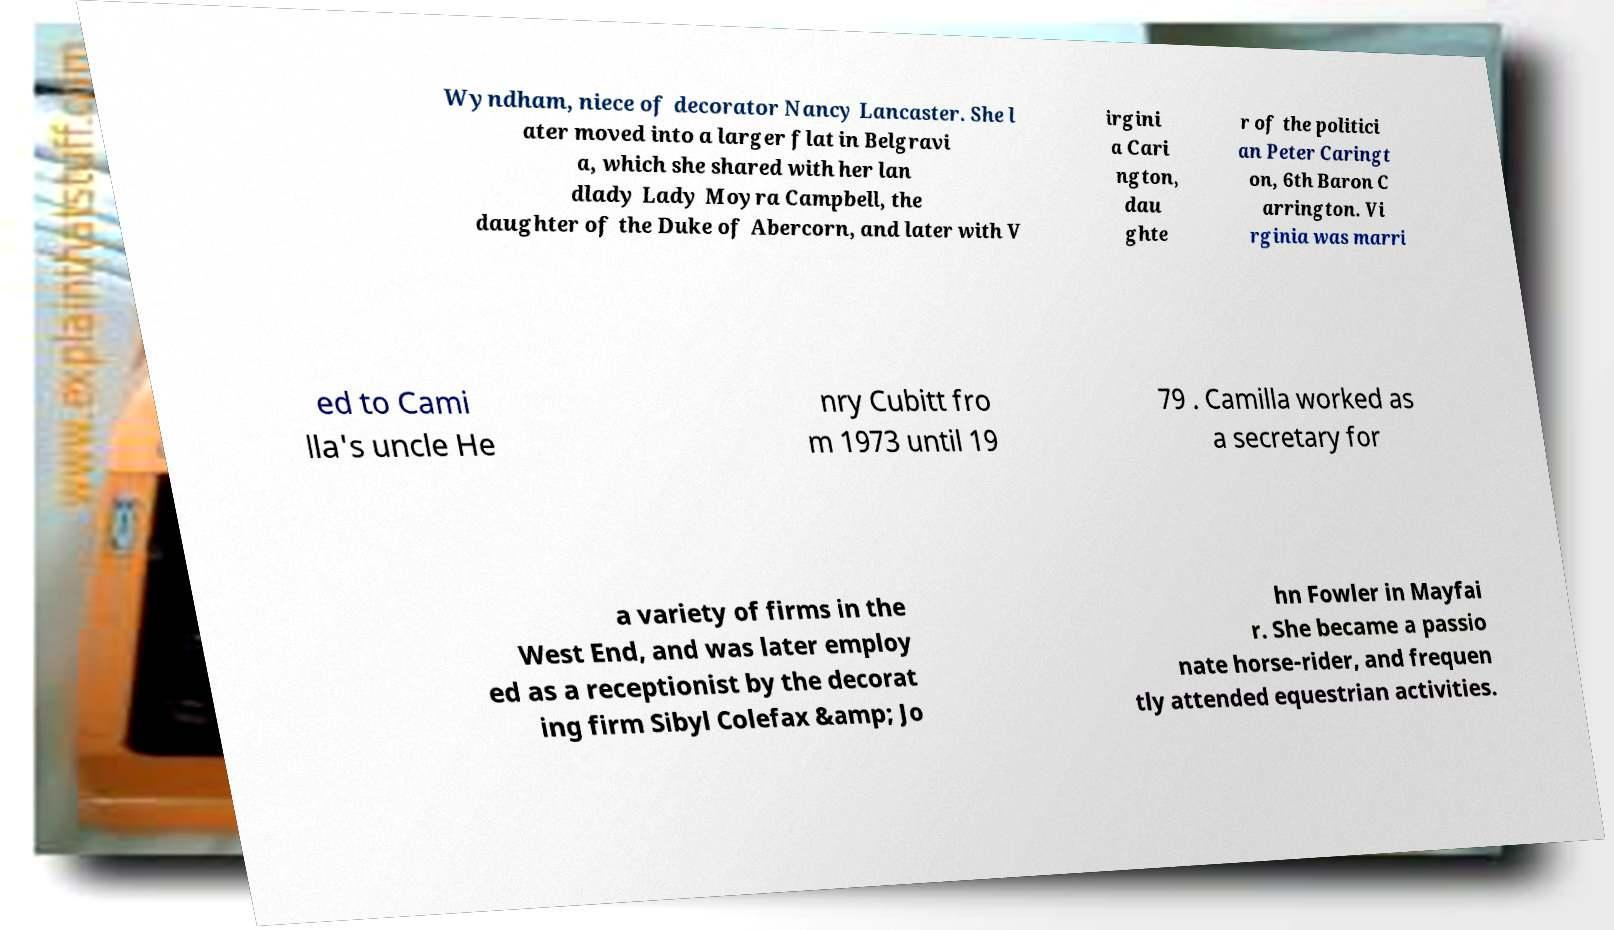I need the written content from this picture converted into text. Can you do that? Wyndham, niece of decorator Nancy Lancaster. She l ater moved into a larger flat in Belgravi a, which she shared with her lan dlady Lady Moyra Campbell, the daughter of the Duke of Abercorn, and later with V irgini a Cari ngton, dau ghte r of the politici an Peter Caringt on, 6th Baron C arrington. Vi rginia was marri ed to Cami lla's uncle He nry Cubitt fro m 1973 until 19 79 . Camilla worked as a secretary for a variety of firms in the West End, and was later employ ed as a receptionist by the decorat ing firm Sibyl Colefax &amp; Jo hn Fowler in Mayfai r. She became a passio nate horse-rider, and frequen tly attended equestrian activities. 